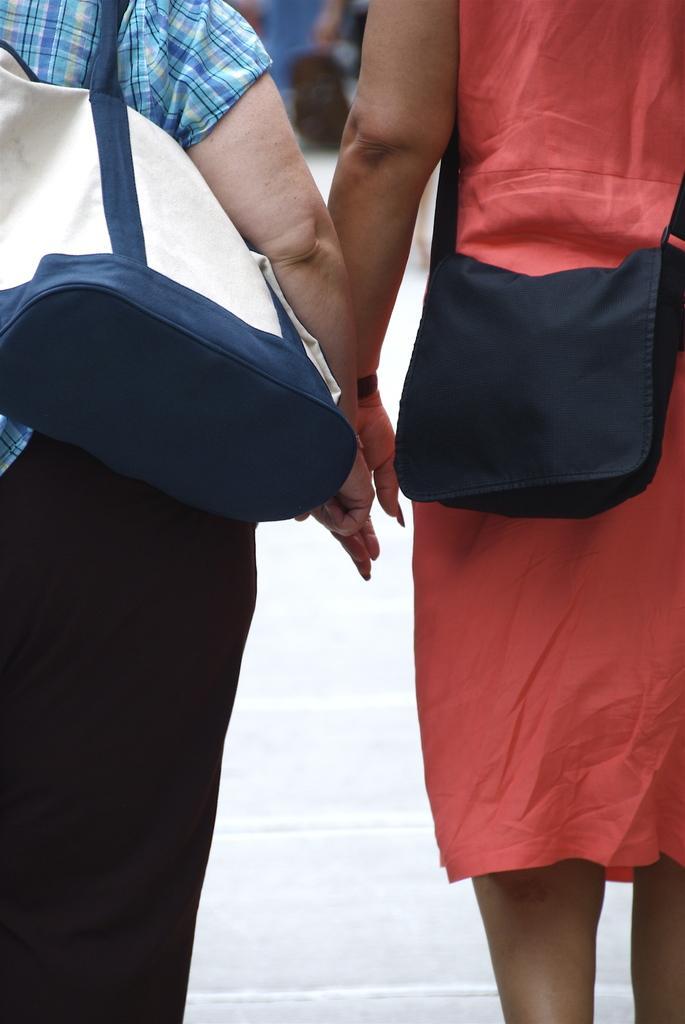Could you give a brief overview of what you see in this image? This picture shows couple of woman standing. They wore handbags, 